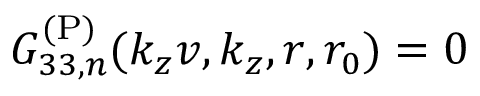<formula> <loc_0><loc_0><loc_500><loc_500>G _ { 3 3 , n } ^ { ( P ) } ( k _ { z } v , k _ { z } , r , r _ { 0 } ) = 0</formula> 